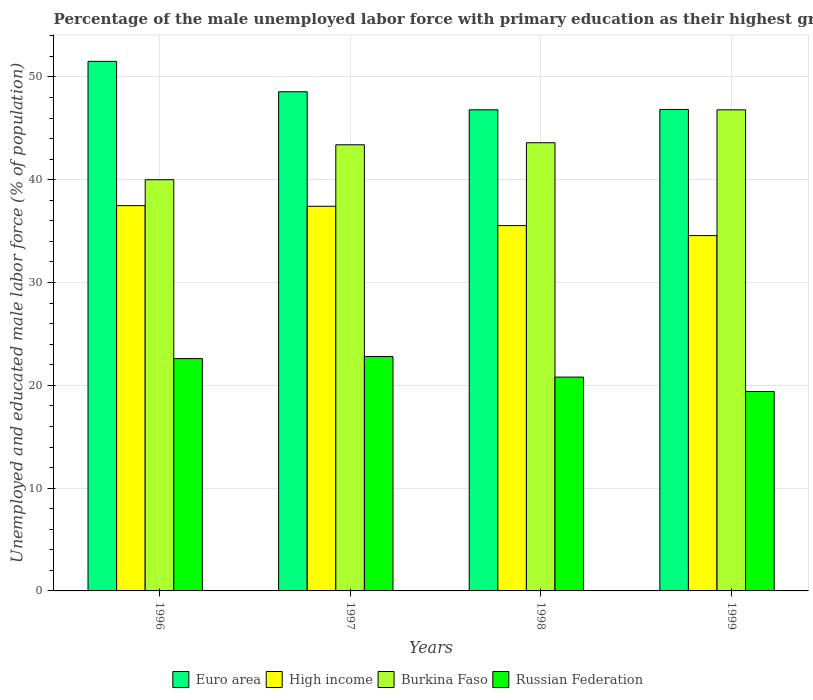How many groups of bars are there?
Offer a very short reply. 4. What is the label of the 2nd group of bars from the left?
Provide a short and direct response. 1997. In how many cases, is the number of bars for a given year not equal to the number of legend labels?
Make the answer very short. 0. What is the percentage of the unemployed male labor force with primary education in Burkina Faso in 1997?
Provide a succinct answer. 43.4. Across all years, what is the maximum percentage of the unemployed male labor force with primary education in Burkina Faso?
Keep it short and to the point. 46.8. Across all years, what is the minimum percentage of the unemployed male labor force with primary education in Burkina Faso?
Keep it short and to the point. 40. In which year was the percentage of the unemployed male labor force with primary education in Russian Federation maximum?
Keep it short and to the point. 1997. What is the total percentage of the unemployed male labor force with primary education in Euro area in the graph?
Provide a short and direct response. 193.72. What is the difference between the percentage of the unemployed male labor force with primary education in Euro area in 1998 and that in 1999?
Provide a short and direct response. -0.03. What is the difference between the percentage of the unemployed male labor force with primary education in Burkina Faso in 1997 and the percentage of the unemployed male labor force with primary education in Russian Federation in 1999?
Your answer should be very brief. 24. What is the average percentage of the unemployed male labor force with primary education in Euro area per year?
Keep it short and to the point. 48.43. In the year 1998, what is the difference between the percentage of the unemployed male labor force with primary education in High income and percentage of the unemployed male labor force with primary education in Russian Federation?
Offer a terse response. 14.74. In how many years, is the percentage of the unemployed male labor force with primary education in Burkina Faso greater than 28 %?
Offer a terse response. 4. What is the ratio of the percentage of the unemployed male labor force with primary education in Burkina Faso in 1997 to that in 1998?
Offer a terse response. 1. What is the difference between the highest and the second highest percentage of the unemployed male labor force with primary education in Burkina Faso?
Ensure brevity in your answer.  3.2. What is the difference between the highest and the lowest percentage of the unemployed male labor force with primary education in Russian Federation?
Your response must be concise. 3.4. Is the sum of the percentage of the unemployed male labor force with primary education in Euro area in 1997 and 1999 greater than the maximum percentage of the unemployed male labor force with primary education in Russian Federation across all years?
Make the answer very short. Yes. Is it the case that in every year, the sum of the percentage of the unemployed male labor force with primary education in Euro area and percentage of the unemployed male labor force with primary education in Russian Federation is greater than the sum of percentage of the unemployed male labor force with primary education in High income and percentage of the unemployed male labor force with primary education in Burkina Faso?
Offer a very short reply. Yes. What does the 1st bar from the left in 1997 represents?
Ensure brevity in your answer.  Euro area. What does the 2nd bar from the right in 1997 represents?
Give a very brief answer. Burkina Faso. Is it the case that in every year, the sum of the percentage of the unemployed male labor force with primary education in Euro area and percentage of the unemployed male labor force with primary education in Burkina Faso is greater than the percentage of the unemployed male labor force with primary education in Russian Federation?
Offer a terse response. Yes. How many years are there in the graph?
Provide a short and direct response. 4. Does the graph contain any zero values?
Give a very brief answer. No. Does the graph contain grids?
Give a very brief answer. Yes. Where does the legend appear in the graph?
Offer a very short reply. Bottom center. How many legend labels are there?
Make the answer very short. 4. How are the legend labels stacked?
Give a very brief answer. Horizontal. What is the title of the graph?
Keep it short and to the point. Percentage of the male unemployed labor force with primary education as their highest grade. What is the label or title of the Y-axis?
Offer a very short reply. Unemployed and educated male labor force (% of population). What is the Unemployed and educated male labor force (% of population) in Euro area in 1996?
Offer a terse response. 51.52. What is the Unemployed and educated male labor force (% of population) of High income in 1996?
Provide a succinct answer. 37.48. What is the Unemployed and educated male labor force (% of population) of Burkina Faso in 1996?
Your answer should be very brief. 40. What is the Unemployed and educated male labor force (% of population) of Russian Federation in 1996?
Keep it short and to the point. 22.6. What is the Unemployed and educated male labor force (% of population) in Euro area in 1997?
Provide a short and direct response. 48.56. What is the Unemployed and educated male labor force (% of population) of High income in 1997?
Offer a terse response. 37.42. What is the Unemployed and educated male labor force (% of population) of Burkina Faso in 1997?
Give a very brief answer. 43.4. What is the Unemployed and educated male labor force (% of population) in Russian Federation in 1997?
Offer a very short reply. 22.8. What is the Unemployed and educated male labor force (% of population) in Euro area in 1998?
Provide a succinct answer. 46.8. What is the Unemployed and educated male labor force (% of population) in High income in 1998?
Your response must be concise. 35.54. What is the Unemployed and educated male labor force (% of population) in Burkina Faso in 1998?
Make the answer very short. 43.6. What is the Unemployed and educated male labor force (% of population) of Russian Federation in 1998?
Provide a succinct answer. 20.8. What is the Unemployed and educated male labor force (% of population) of Euro area in 1999?
Your answer should be compact. 46.84. What is the Unemployed and educated male labor force (% of population) of High income in 1999?
Offer a very short reply. 34.57. What is the Unemployed and educated male labor force (% of population) in Burkina Faso in 1999?
Your answer should be compact. 46.8. What is the Unemployed and educated male labor force (% of population) of Russian Federation in 1999?
Ensure brevity in your answer.  19.4. Across all years, what is the maximum Unemployed and educated male labor force (% of population) of Euro area?
Offer a terse response. 51.52. Across all years, what is the maximum Unemployed and educated male labor force (% of population) in High income?
Your response must be concise. 37.48. Across all years, what is the maximum Unemployed and educated male labor force (% of population) of Burkina Faso?
Make the answer very short. 46.8. Across all years, what is the maximum Unemployed and educated male labor force (% of population) of Russian Federation?
Your response must be concise. 22.8. Across all years, what is the minimum Unemployed and educated male labor force (% of population) of Euro area?
Ensure brevity in your answer.  46.8. Across all years, what is the minimum Unemployed and educated male labor force (% of population) in High income?
Give a very brief answer. 34.57. Across all years, what is the minimum Unemployed and educated male labor force (% of population) in Burkina Faso?
Make the answer very short. 40. Across all years, what is the minimum Unemployed and educated male labor force (% of population) in Russian Federation?
Offer a very short reply. 19.4. What is the total Unemployed and educated male labor force (% of population) of Euro area in the graph?
Your answer should be very brief. 193.72. What is the total Unemployed and educated male labor force (% of population) in High income in the graph?
Offer a very short reply. 145. What is the total Unemployed and educated male labor force (% of population) in Burkina Faso in the graph?
Your answer should be compact. 173.8. What is the total Unemployed and educated male labor force (% of population) in Russian Federation in the graph?
Provide a succinct answer. 85.6. What is the difference between the Unemployed and educated male labor force (% of population) in Euro area in 1996 and that in 1997?
Provide a short and direct response. 2.96. What is the difference between the Unemployed and educated male labor force (% of population) in High income in 1996 and that in 1997?
Provide a short and direct response. 0.06. What is the difference between the Unemployed and educated male labor force (% of population) of Euro area in 1996 and that in 1998?
Your answer should be compact. 4.71. What is the difference between the Unemployed and educated male labor force (% of population) of High income in 1996 and that in 1998?
Make the answer very short. 1.94. What is the difference between the Unemployed and educated male labor force (% of population) of Burkina Faso in 1996 and that in 1998?
Make the answer very short. -3.6. What is the difference between the Unemployed and educated male labor force (% of population) of Russian Federation in 1996 and that in 1998?
Your answer should be very brief. 1.8. What is the difference between the Unemployed and educated male labor force (% of population) of Euro area in 1996 and that in 1999?
Your response must be concise. 4.68. What is the difference between the Unemployed and educated male labor force (% of population) in High income in 1996 and that in 1999?
Offer a very short reply. 2.91. What is the difference between the Unemployed and educated male labor force (% of population) in Russian Federation in 1996 and that in 1999?
Provide a succinct answer. 3.2. What is the difference between the Unemployed and educated male labor force (% of population) in Euro area in 1997 and that in 1998?
Provide a succinct answer. 1.76. What is the difference between the Unemployed and educated male labor force (% of population) in High income in 1997 and that in 1998?
Your answer should be very brief. 1.88. What is the difference between the Unemployed and educated male labor force (% of population) in Burkina Faso in 1997 and that in 1998?
Give a very brief answer. -0.2. What is the difference between the Unemployed and educated male labor force (% of population) in Russian Federation in 1997 and that in 1998?
Provide a short and direct response. 2. What is the difference between the Unemployed and educated male labor force (% of population) of Euro area in 1997 and that in 1999?
Your response must be concise. 1.72. What is the difference between the Unemployed and educated male labor force (% of population) of High income in 1997 and that in 1999?
Keep it short and to the point. 2.85. What is the difference between the Unemployed and educated male labor force (% of population) in Euro area in 1998 and that in 1999?
Provide a succinct answer. -0.03. What is the difference between the Unemployed and educated male labor force (% of population) in High income in 1998 and that in 1999?
Offer a very short reply. 0.97. What is the difference between the Unemployed and educated male labor force (% of population) of Burkina Faso in 1998 and that in 1999?
Offer a very short reply. -3.2. What is the difference between the Unemployed and educated male labor force (% of population) of Russian Federation in 1998 and that in 1999?
Ensure brevity in your answer.  1.4. What is the difference between the Unemployed and educated male labor force (% of population) in Euro area in 1996 and the Unemployed and educated male labor force (% of population) in High income in 1997?
Your response must be concise. 14.1. What is the difference between the Unemployed and educated male labor force (% of population) in Euro area in 1996 and the Unemployed and educated male labor force (% of population) in Burkina Faso in 1997?
Your answer should be compact. 8.12. What is the difference between the Unemployed and educated male labor force (% of population) in Euro area in 1996 and the Unemployed and educated male labor force (% of population) in Russian Federation in 1997?
Provide a short and direct response. 28.72. What is the difference between the Unemployed and educated male labor force (% of population) of High income in 1996 and the Unemployed and educated male labor force (% of population) of Burkina Faso in 1997?
Offer a very short reply. -5.92. What is the difference between the Unemployed and educated male labor force (% of population) of High income in 1996 and the Unemployed and educated male labor force (% of population) of Russian Federation in 1997?
Ensure brevity in your answer.  14.68. What is the difference between the Unemployed and educated male labor force (% of population) of Euro area in 1996 and the Unemployed and educated male labor force (% of population) of High income in 1998?
Offer a terse response. 15.98. What is the difference between the Unemployed and educated male labor force (% of population) of Euro area in 1996 and the Unemployed and educated male labor force (% of population) of Burkina Faso in 1998?
Provide a short and direct response. 7.92. What is the difference between the Unemployed and educated male labor force (% of population) of Euro area in 1996 and the Unemployed and educated male labor force (% of population) of Russian Federation in 1998?
Give a very brief answer. 30.72. What is the difference between the Unemployed and educated male labor force (% of population) of High income in 1996 and the Unemployed and educated male labor force (% of population) of Burkina Faso in 1998?
Ensure brevity in your answer.  -6.12. What is the difference between the Unemployed and educated male labor force (% of population) of High income in 1996 and the Unemployed and educated male labor force (% of population) of Russian Federation in 1998?
Provide a succinct answer. 16.68. What is the difference between the Unemployed and educated male labor force (% of population) of Burkina Faso in 1996 and the Unemployed and educated male labor force (% of population) of Russian Federation in 1998?
Your answer should be very brief. 19.2. What is the difference between the Unemployed and educated male labor force (% of population) of Euro area in 1996 and the Unemployed and educated male labor force (% of population) of High income in 1999?
Keep it short and to the point. 16.95. What is the difference between the Unemployed and educated male labor force (% of population) in Euro area in 1996 and the Unemployed and educated male labor force (% of population) in Burkina Faso in 1999?
Your answer should be very brief. 4.72. What is the difference between the Unemployed and educated male labor force (% of population) of Euro area in 1996 and the Unemployed and educated male labor force (% of population) of Russian Federation in 1999?
Make the answer very short. 32.12. What is the difference between the Unemployed and educated male labor force (% of population) of High income in 1996 and the Unemployed and educated male labor force (% of population) of Burkina Faso in 1999?
Provide a short and direct response. -9.32. What is the difference between the Unemployed and educated male labor force (% of population) of High income in 1996 and the Unemployed and educated male labor force (% of population) of Russian Federation in 1999?
Your response must be concise. 18.08. What is the difference between the Unemployed and educated male labor force (% of population) of Burkina Faso in 1996 and the Unemployed and educated male labor force (% of population) of Russian Federation in 1999?
Provide a succinct answer. 20.6. What is the difference between the Unemployed and educated male labor force (% of population) of Euro area in 1997 and the Unemployed and educated male labor force (% of population) of High income in 1998?
Offer a terse response. 13.02. What is the difference between the Unemployed and educated male labor force (% of population) of Euro area in 1997 and the Unemployed and educated male labor force (% of population) of Burkina Faso in 1998?
Ensure brevity in your answer.  4.96. What is the difference between the Unemployed and educated male labor force (% of population) of Euro area in 1997 and the Unemployed and educated male labor force (% of population) of Russian Federation in 1998?
Your response must be concise. 27.76. What is the difference between the Unemployed and educated male labor force (% of population) of High income in 1997 and the Unemployed and educated male labor force (% of population) of Burkina Faso in 1998?
Provide a succinct answer. -6.18. What is the difference between the Unemployed and educated male labor force (% of population) of High income in 1997 and the Unemployed and educated male labor force (% of population) of Russian Federation in 1998?
Your response must be concise. 16.62. What is the difference between the Unemployed and educated male labor force (% of population) in Burkina Faso in 1997 and the Unemployed and educated male labor force (% of population) in Russian Federation in 1998?
Provide a short and direct response. 22.6. What is the difference between the Unemployed and educated male labor force (% of population) in Euro area in 1997 and the Unemployed and educated male labor force (% of population) in High income in 1999?
Ensure brevity in your answer.  13.99. What is the difference between the Unemployed and educated male labor force (% of population) of Euro area in 1997 and the Unemployed and educated male labor force (% of population) of Burkina Faso in 1999?
Your answer should be very brief. 1.76. What is the difference between the Unemployed and educated male labor force (% of population) in Euro area in 1997 and the Unemployed and educated male labor force (% of population) in Russian Federation in 1999?
Ensure brevity in your answer.  29.16. What is the difference between the Unemployed and educated male labor force (% of population) in High income in 1997 and the Unemployed and educated male labor force (% of population) in Burkina Faso in 1999?
Offer a very short reply. -9.38. What is the difference between the Unemployed and educated male labor force (% of population) of High income in 1997 and the Unemployed and educated male labor force (% of population) of Russian Federation in 1999?
Keep it short and to the point. 18.02. What is the difference between the Unemployed and educated male labor force (% of population) of Euro area in 1998 and the Unemployed and educated male labor force (% of population) of High income in 1999?
Your response must be concise. 12.24. What is the difference between the Unemployed and educated male labor force (% of population) in Euro area in 1998 and the Unemployed and educated male labor force (% of population) in Burkina Faso in 1999?
Your response must be concise. 0. What is the difference between the Unemployed and educated male labor force (% of population) in Euro area in 1998 and the Unemployed and educated male labor force (% of population) in Russian Federation in 1999?
Provide a succinct answer. 27.4. What is the difference between the Unemployed and educated male labor force (% of population) in High income in 1998 and the Unemployed and educated male labor force (% of population) in Burkina Faso in 1999?
Your answer should be compact. -11.26. What is the difference between the Unemployed and educated male labor force (% of population) of High income in 1998 and the Unemployed and educated male labor force (% of population) of Russian Federation in 1999?
Provide a short and direct response. 16.14. What is the difference between the Unemployed and educated male labor force (% of population) in Burkina Faso in 1998 and the Unemployed and educated male labor force (% of population) in Russian Federation in 1999?
Provide a succinct answer. 24.2. What is the average Unemployed and educated male labor force (% of population) in Euro area per year?
Your response must be concise. 48.43. What is the average Unemployed and educated male labor force (% of population) in High income per year?
Give a very brief answer. 36.25. What is the average Unemployed and educated male labor force (% of population) in Burkina Faso per year?
Ensure brevity in your answer.  43.45. What is the average Unemployed and educated male labor force (% of population) in Russian Federation per year?
Ensure brevity in your answer.  21.4. In the year 1996, what is the difference between the Unemployed and educated male labor force (% of population) of Euro area and Unemployed and educated male labor force (% of population) of High income?
Offer a terse response. 14.04. In the year 1996, what is the difference between the Unemployed and educated male labor force (% of population) in Euro area and Unemployed and educated male labor force (% of population) in Burkina Faso?
Your response must be concise. 11.52. In the year 1996, what is the difference between the Unemployed and educated male labor force (% of population) in Euro area and Unemployed and educated male labor force (% of population) in Russian Federation?
Offer a very short reply. 28.92. In the year 1996, what is the difference between the Unemployed and educated male labor force (% of population) in High income and Unemployed and educated male labor force (% of population) in Burkina Faso?
Your response must be concise. -2.52. In the year 1996, what is the difference between the Unemployed and educated male labor force (% of population) of High income and Unemployed and educated male labor force (% of population) of Russian Federation?
Your answer should be very brief. 14.88. In the year 1997, what is the difference between the Unemployed and educated male labor force (% of population) in Euro area and Unemployed and educated male labor force (% of population) in High income?
Give a very brief answer. 11.14. In the year 1997, what is the difference between the Unemployed and educated male labor force (% of population) of Euro area and Unemployed and educated male labor force (% of population) of Burkina Faso?
Provide a short and direct response. 5.16. In the year 1997, what is the difference between the Unemployed and educated male labor force (% of population) in Euro area and Unemployed and educated male labor force (% of population) in Russian Federation?
Make the answer very short. 25.76. In the year 1997, what is the difference between the Unemployed and educated male labor force (% of population) in High income and Unemployed and educated male labor force (% of population) in Burkina Faso?
Your answer should be very brief. -5.98. In the year 1997, what is the difference between the Unemployed and educated male labor force (% of population) in High income and Unemployed and educated male labor force (% of population) in Russian Federation?
Provide a succinct answer. 14.62. In the year 1997, what is the difference between the Unemployed and educated male labor force (% of population) in Burkina Faso and Unemployed and educated male labor force (% of population) in Russian Federation?
Keep it short and to the point. 20.6. In the year 1998, what is the difference between the Unemployed and educated male labor force (% of population) of Euro area and Unemployed and educated male labor force (% of population) of High income?
Ensure brevity in your answer.  11.27. In the year 1998, what is the difference between the Unemployed and educated male labor force (% of population) of Euro area and Unemployed and educated male labor force (% of population) of Burkina Faso?
Ensure brevity in your answer.  3.2. In the year 1998, what is the difference between the Unemployed and educated male labor force (% of population) in Euro area and Unemployed and educated male labor force (% of population) in Russian Federation?
Your answer should be very brief. 26. In the year 1998, what is the difference between the Unemployed and educated male labor force (% of population) in High income and Unemployed and educated male labor force (% of population) in Burkina Faso?
Offer a very short reply. -8.06. In the year 1998, what is the difference between the Unemployed and educated male labor force (% of population) in High income and Unemployed and educated male labor force (% of population) in Russian Federation?
Offer a very short reply. 14.74. In the year 1998, what is the difference between the Unemployed and educated male labor force (% of population) of Burkina Faso and Unemployed and educated male labor force (% of population) of Russian Federation?
Provide a short and direct response. 22.8. In the year 1999, what is the difference between the Unemployed and educated male labor force (% of population) in Euro area and Unemployed and educated male labor force (% of population) in High income?
Give a very brief answer. 12.27. In the year 1999, what is the difference between the Unemployed and educated male labor force (% of population) in Euro area and Unemployed and educated male labor force (% of population) in Burkina Faso?
Make the answer very short. 0.04. In the year 1999, what is the difference between the Unemployed and educated male labor force (% of population) in Euro area and Unemployed and educated male labor force (% of population) in Russian Federation?
Keep it short and to the point. 27.44. In the year 1999, what is the difference between the Unemployed and educated male labor force (% of population) in High income and Unemployed and educated male labor force (% of population) in Burkina Faso?
Your response must be concise. -12.23. In the year 1999, what is the difference between the Unemployed and educated male labor force (% of population) of High income and Unemployed and educated male labor force (% of population) of Russian Federation?
Ensure brevity in your answer.  15.17. In the year 1999, what is the difference between the Unemployed and educated male labor force (% of population) in Burkina Faso and Unemployed and educated male labor force (% of population) in Russian Federation?
Your answer should be compact. 27.4. What is the ratio of the Unemployed and educated male labor force (% of population) of Euro area in 1996 to that in 1997?
Your answer should be compact. 1.06. What is the ratio of the Unemployed and educated male labor force (% of population) in High income in 1996 to that in 1997?
Offer a terse response. 1. What is the ratio of the Unemployed and educated male labor force (% of population) of Burkina Faso in 1996 to that in 1997?
Your answer should be compact. 0.92. What is the ratio of the Unemployed and educated male labor force (% of population) of Euro area in 1996 to that in 1998?
Keep it short and to the point. 1.1. What is the ratio of the Unemployed and educated male labor force (% of population) of High income in 1996 to that in 1998?
Your answer should be compact. 1.05. What is the ratio of the Unemployed and educated male labor force (% of population) of Burkina Faso in 1996 to that in 1998?
Offer a very short reply. 0.92. What is the ratio of the Unemployed and educated male labor force (% of population) of Russian Federation in 1996 to that in 1998?
Offer a terse response. 1.09. What is the ratio of the Unemployed and educated male labor force (% of population) of Euro area in 1996 to that in 1999?
Provide a short and direct response. 1.1. What is the ratio of the Unemployed and educated male labor force (% of population) in High income in 1996 to that in 1999?
Your answer should be compact. 1.08. What is the ratio of the Unemployed and educated male labor force (% of population) in Burkina Faso in 1996 to that in 1999?
Make the answer very short. 0.85. What is the ratio of the Unemployed and educated male labor force (% of population) in Russian Federation in 1996 to that in 1999?
Provide a short and direct response. 1.16. What is the ratio of the Unemployed and educated male labor force (% of population) of Euro area in 1997 to that in 1998?
Your answer should be very brief. 1.04. What is the ratio of the Unemployed and educated male labor force (% of population) in High income in 1997 to that in 1998?
Your response must be concise. 1.05. What is the ratio of the Unemployed and educated male labor force (% of population) of Russian Federation in 1997 to that in 1998?
Your answer should be very brief. 1.1. What is the ratio of the Unemployed and educated male labor force (% of population) of Euro area in 1997 to that in 1999?
Your response must be concise. 1.04. What is the ratio of the Unemployed and educated male labor force (% of population) in High income in 1997 to that in 1999?
Give a very brief answer. 1.08. What is the ratio of the Unemployed and educated male labor force (% of population) of Burkina Faso in 1997 to that in 1999?
Your response must be concise. 0.93. What is the ratio of the Unemployed and educated male labor force (% of population) in Russian Federation in 1997 to that in 1999?
Your response must be concise. 1.18. What is the ratio of the Unemployed and educated male labor force (% of population) of High income in 1998 to that in 1999?
Give a very brief answer. 1.03. What is the ratio of the Unemployed and educated male labor force (% of population) of Burkina Faso in 1998 to that in 1999?
Offer a very short reply. 0.93. What is the ratio of the Unemployed and educated male labor force (% of population) in Russian Federation in 1998 to that in 1999?
Make the answer very short. 1.07. What is the difference between the highest and the second highest Unemployed and educated male labor force (% of population) in Euro area?
Give a very brief answer. 2.96. What is the difference between the highest and the second highest Unemployed and educated male labor force (% of population) in High income?
Provide a short and direct response. 0.06. What is the difference between the highest and the second highest Unemployed and educated male labor force (% of population) of Burkina Faso?
Your answer should be very brief. 3.2. What is the difference between the highest and the second highest Unemployed and educated male labor force (% of population) in Russian Federation?
Provide a succinct answer. 0.2. What is the difference between the highest and the lowest Unemployed and educated male labor force (% of population) in Euro area?
Offer a terse response. 4.71. What is the difference between the highest and the lowest Unemployed and educated male labor force (% of population) in High income?
Keep it short and to the point. 2.91. What is the difference between the highest and the lowest Unemployed and educated male labor force (% of population) in Burkina Faso?
Offer a terse response. 6.8. 